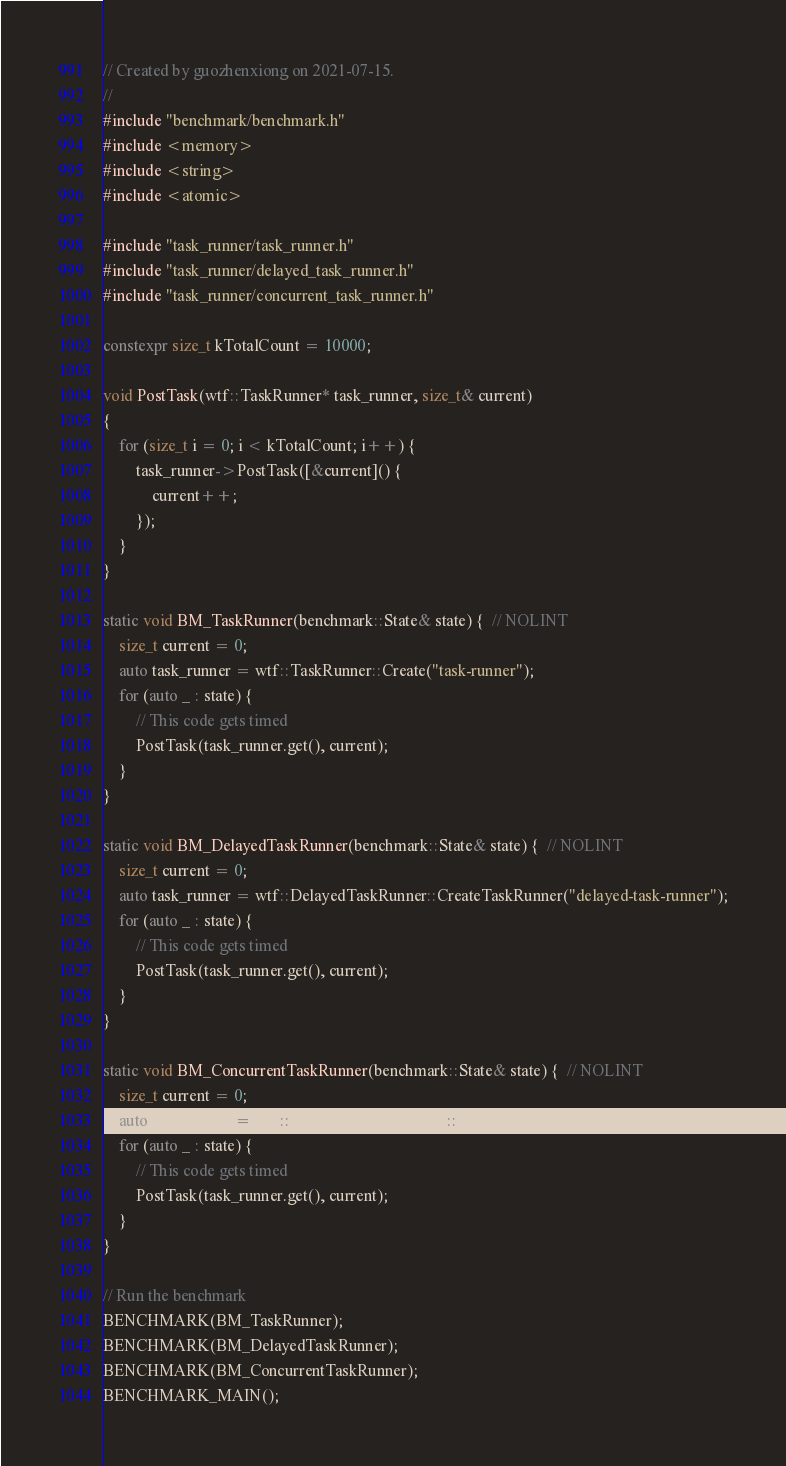Convert code to text. <code><loc_0><loc_0><loc_500><loc_500><_C++_>// Created by guozhenxiong on 2021-07-15.
//
#include "benchmark/benchmark.h"
#include <memory>
#include <string>
#include <atomic>

#include "task_runner/task_runner.h"
#include "task_runner/delayed_task_runner.h"
#include "task_runner/concurrent_task_runner.h"

constexpr size_t kTotalCount = 10000;

void PostTask(wtf::TaskRunner* task_runner, size_t& current)
{
    for (size_t i = 0; i < kTotalCount; i++) {
        task_runner->PostTask([&current]() {
            current++;
        });
    }
}

static void BM_TaskRunner(benchmark::State& state) {  // NOLINT
    size_t current = 0;
    auto task_runner = wtf::TaskRunner::Create("task-runner");
    for (auto _ : state) {
        // This code gets timed
        PostTask(task_runner.get(), current);
    }
}

static void BM_DelayedTaskRunner(benchmark::State& state) {  // NOLINT
    size_t current = 0;
    auto task_runner = wtf::DelayedTaskRunner::CreateTaskRunner("delayed-task-runner");
    for (auto _ : state) {
        // This code gets timed
        PostTask(task_runner.get(), current);
    }
}

static void BM_ConcurrentTaskRunner(benchmark::State& state) {  // NOLINT
    size_t current = 0;
    auto task_runner = wtf::ConcurrentTaskRunner::Create();
    for (auto _ : state) {
        // This code gets timed
        PostTask(task_runner.get(), current);
    }
}

// Run the benchmark
BENCHMARK(BM_TaskRunner);
BENCHMARK(BM_DelayedTaskRunner);
BENCHMARK(BM_ConcurrentTaskRunner);
BENCHMARK_MAIN();</code> 